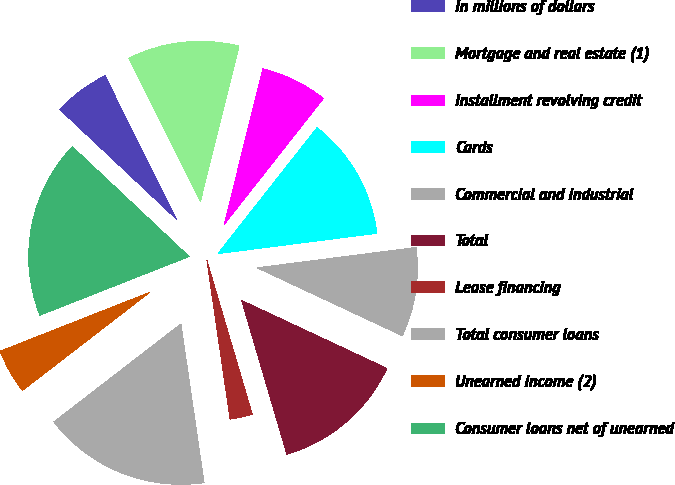Convert chart to OTSL. <chart><loc_0><loc_0><loc_500><loc_500><pie_chart><fcel>In millions of dollars<fcel>Mortgage and real estate (1)<fcel>Installment revolving credit<fcel>Cards<fcel>Commercial and industrial<fcel>Total<fcel>Lease financing<fcel>Total consumer loans<fcel>Unearned income (2)<fcel>Consumer loans net of unearned<nl><fcel>5.62%<fcel>11.24%<fcel>6.74%<fcel>12.36%<fcel>8.99%<fcel>13.48%<fcel>2.25%<fcel>16.85%<fcel>4.49%<fcel>17.98%<nl></chart> 